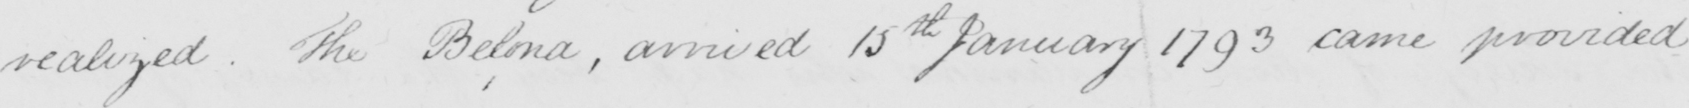Can you read and transcribe this handwriting? realized . The Bel ona , arrived 15th January 1793 came provided 